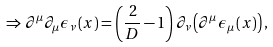<formula> <loc_0><loc_0><loc_500><loc_500>\Rightarrow \partial ^ { \mu } \partial _ { \mu } \epsilon _ { \nu } \left ( x \right ) = \left ( \frac { 2 } { D } - 1 \right ) \partial _ { \nu } \left ( \partial ^ { \mu } \epsilon _ { \mu } \left ( x \right ) \right ) ,</formula> 